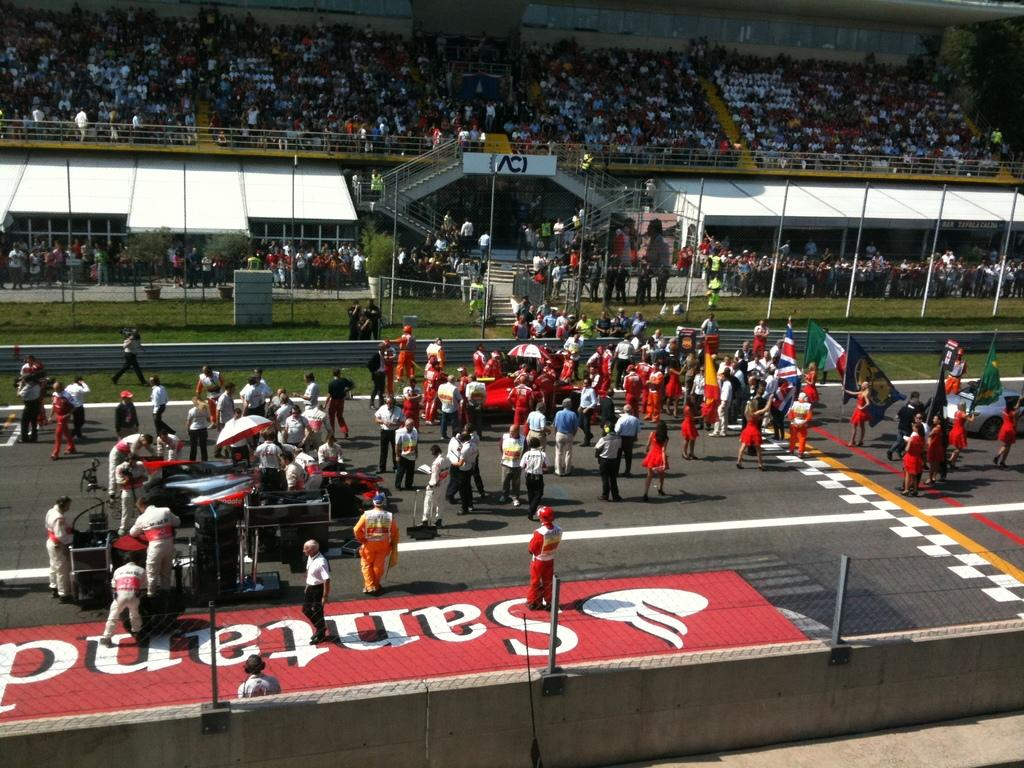<image>
Give a short and clear explanation of the subsequent image. A group of people on a track and in the stands, some standing on the world Santand. 